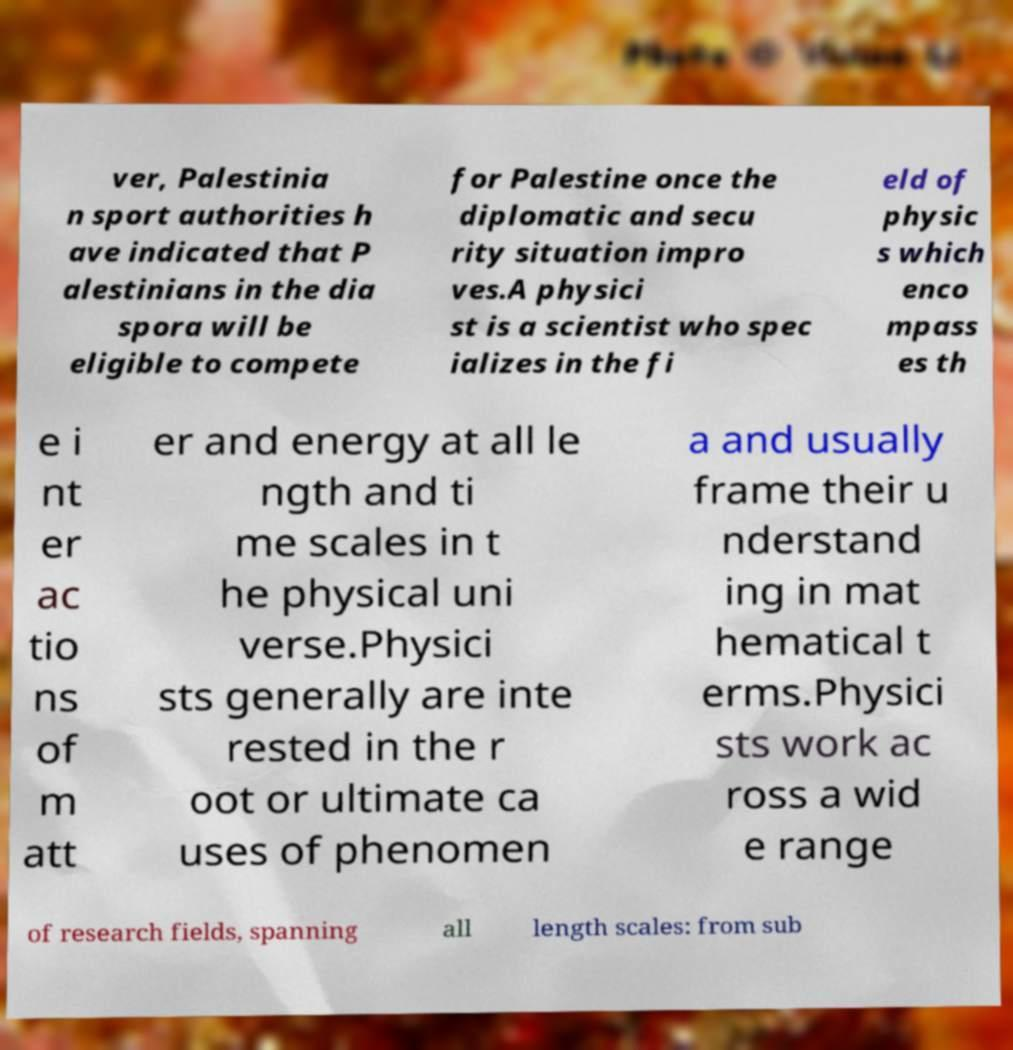Can you read and provide the text displayed in the image?This photo seems to have some interesting text. Can you extract and type it out for me? ver, Palestinia n sport authorities h ave indicated that P alestinians in the dia spora will be eligible to compete for Palestine once the diplomatic and secu rity situation impro ves.A physici st is a scientist who spec ializes in the fi eld of physic s which enco mpass es th e i nt er ac tio ns of m att er and energy at all le ngth and ti me scales in t he physical uni verse.Physici sts generally are inte rested in the r oot or ultimate ca uses of phenomen a and usually frame their u nderstand ing in mat hematical t erms.Physici sts work ac ross a wid e range of research fields, spanning all length scales: from sub 